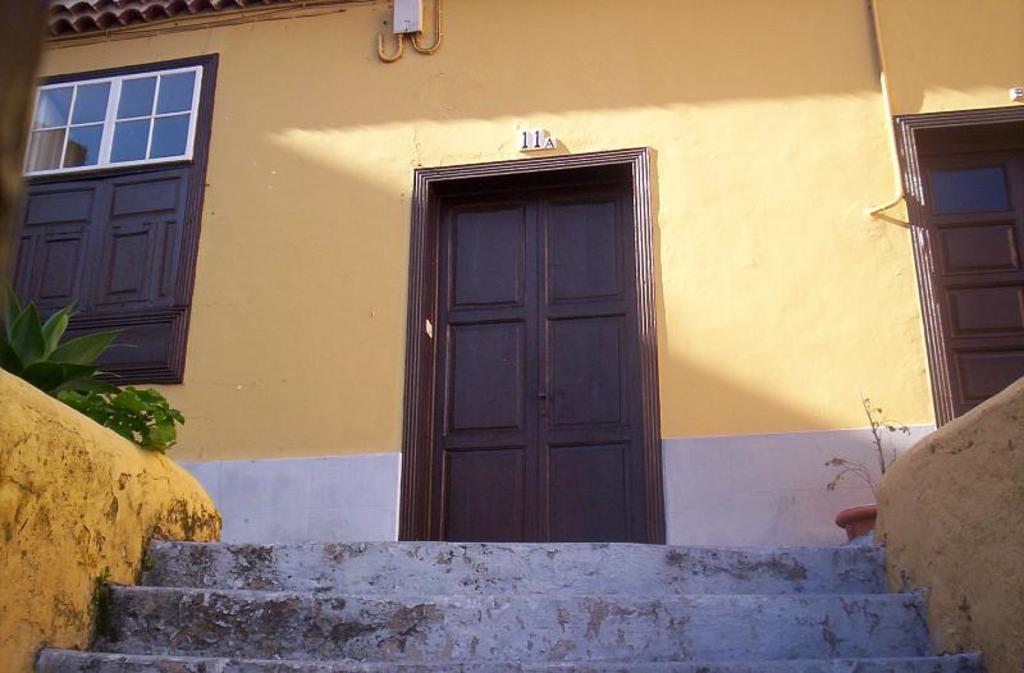Can you describe this image briefly? This is a building with doors and window. In front of the building there are steps. On the left side there are plants. And on the right side there is a pot. 